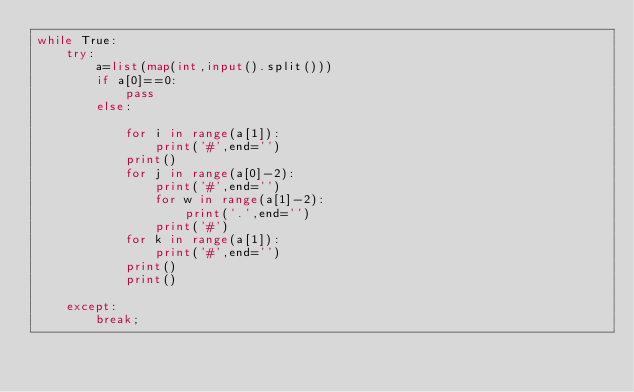Convert code to text. <code><loc_0><loc_0><loc_500><loc_500><_Python_>while True:
    try:
        a=list(map(int,input().split()))
        if a[0]==0:
            pass
        else:
            
            for i in range(a[1]):
                print('#',end='')
            print()
            for j in range(a[0]-2):
                print('#',end='')
                for w in range(a[1]-2):
                    print('.',end='')
                print('#')
            for k in range(a[1]):
                print('#',end='')
            print()
            print()
        
    except:
        break;
</code> 